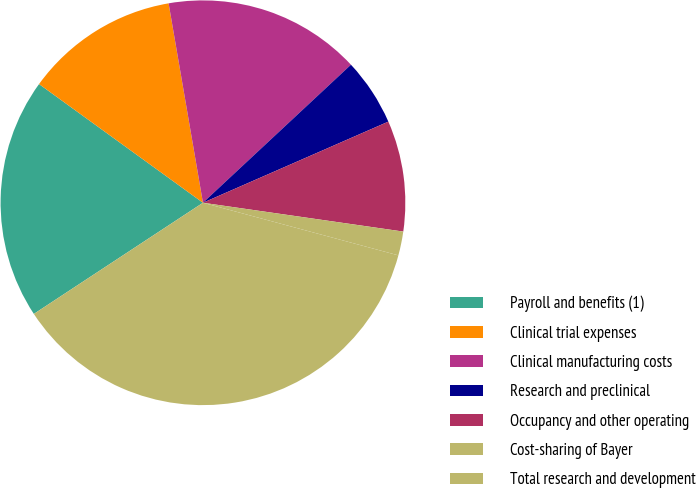Convert chart to OTSL. <chart><loc_0><loc_0><loc_500><loc_500><pie_chart><fcel>Payroll and benefits (1)<fcel>Clinical trial expenses<fcel>Clinical manufacturing costs<fcel>Research and preclinical<fcel>Occupancy and other operating<fcel>Cost-sharing of Bayer<fcel>Total research and development<nl><fcel>19.23%<fcel>12.31%<fcel>15.77%<fcel>5.38%<fcel>8.84%<fcel>1.91%<fcel>36.56%<nl></chart> 